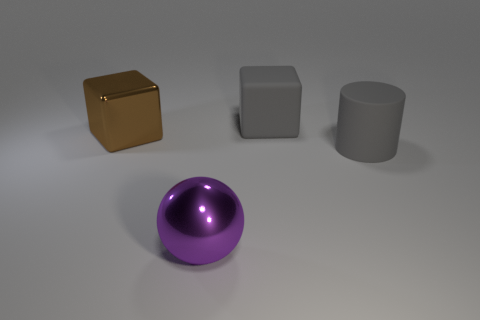Add 2 big purple matte things. How many objects exist? 6 Subtract all brown blocks. How many blocks are left? 1 Subtract 1 cylinders. How many cylinders are left? 0 Subtract all green cubes. Subtract all gray cylinders. How many cubes are left? 2 Subtract all red spheres. How many green cylinders are left? 0 Subtract all large matte blocks. Subtract all gray things. How many objects are left? 1 Add 4 purple metal balls. How many purple metal balls are left? 5 Add 1 large shiny spheres. How many large shiny spheres exist? 2 Subtract 0 blue cubes. How many objects are left? 4 